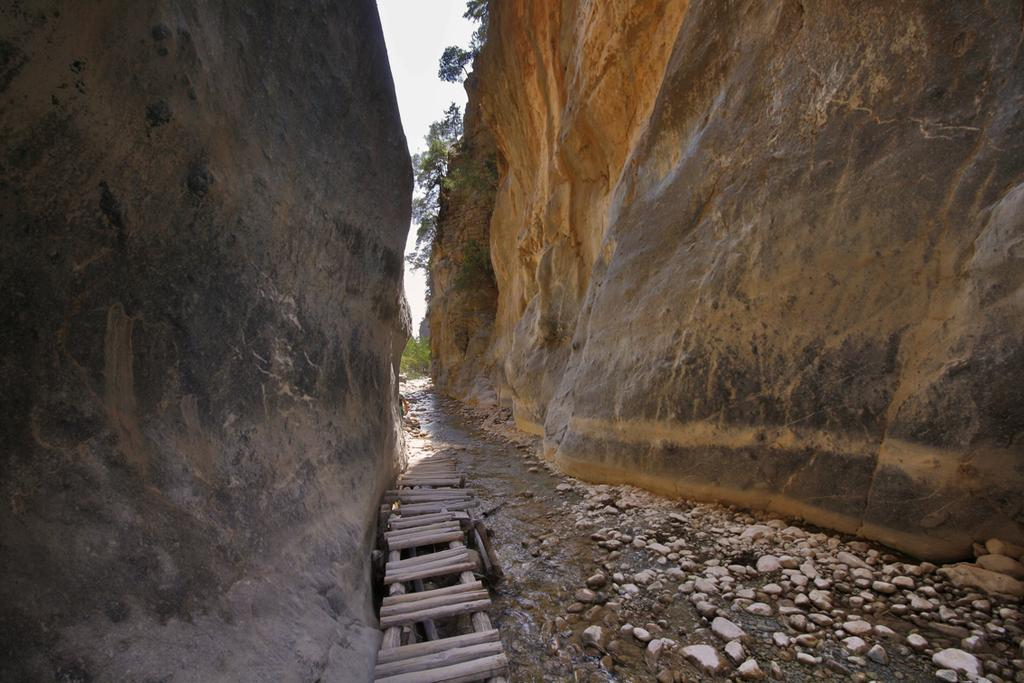What type of natural landscape is depicted in the image? There are hills in the image. What object can be seen in the image that might be used for climbing or reaching higher places? There is a ladder in the image. What type of ground surface is visible in the image? There are stones in the image. What type of vegetation is present in the image? There are trees in the image. What is visible in the background of the image? The sky is visible in the image. Where is the sofa located in the image? There is no sofa present in the image. How many planes can be seen flying in the sky in the image? There are no planes visible in the image; only the sky is visible. 